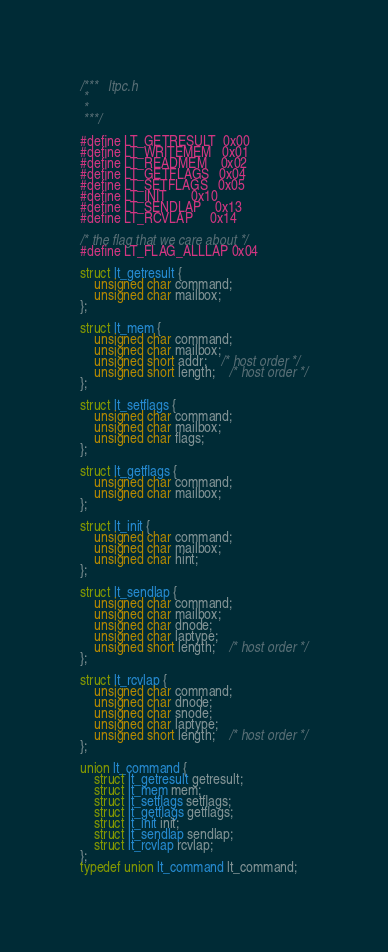<code> <loc_0><loc_0><loc_500><loc_500><_C_>/***   ltpc.h
 *
 *
 ***/

#define LT_GETRESULT  0x00
#define LT_WRITEMEM   0x01
#define LT_READMEM    0x02
#define LT_GETFLAGS   0x04
#define LT_SETFLAGS   0x05
#define LT_INIT       0x10
#define LT_SENDLAP    0x13
#define LT_RCVLAP     0x14

/* the flag that we care about */
#define LT_FLAG_ALLLAP 0x04

struct lt_getresult {
	unsigned char command;
	unsigned char mailbox;
};

struct lt_mem {
	unsigned char command;
	unsigned char mailbox;
	unsigned short addr;	/* host order */
	unsigned short length;	/* host order */
};

struct lt_setflags {
	unsigned char command;
	unsigned char mailbox;
	unsigned char flags;
};

struct lt_getflags {
	unsigned char command;
	unsigned char mailbox;
};

struct lt_init {
	unsigned char command;
	unsigned char mailbox;
	unsigned char hint;
};

struct lt_sendlap {
	unsigned char command;
	unsigned char mailbox;
	unsigned char dnode;
	unsigned char laptype;
	unsigned short length;	/* host order */
};

struct lt_rcvlap {
	unsigned char command;
	unsigned char dnode;
	unsigned char snode;
	unsigned char laptype;
	unsigned short length;	/* host order */
};

union lt_command {
	struct lt_getresult getresult;
	struct lt_mem mem;
	struct lt_setflags setflags;
	struct lt_getflags getflags;
	struct lt_init init;
	struct lt_sendlap sendlap;
	struct lt_rcvlap rcvlap;
};
typedef union lt_command lt_command;
</code> 